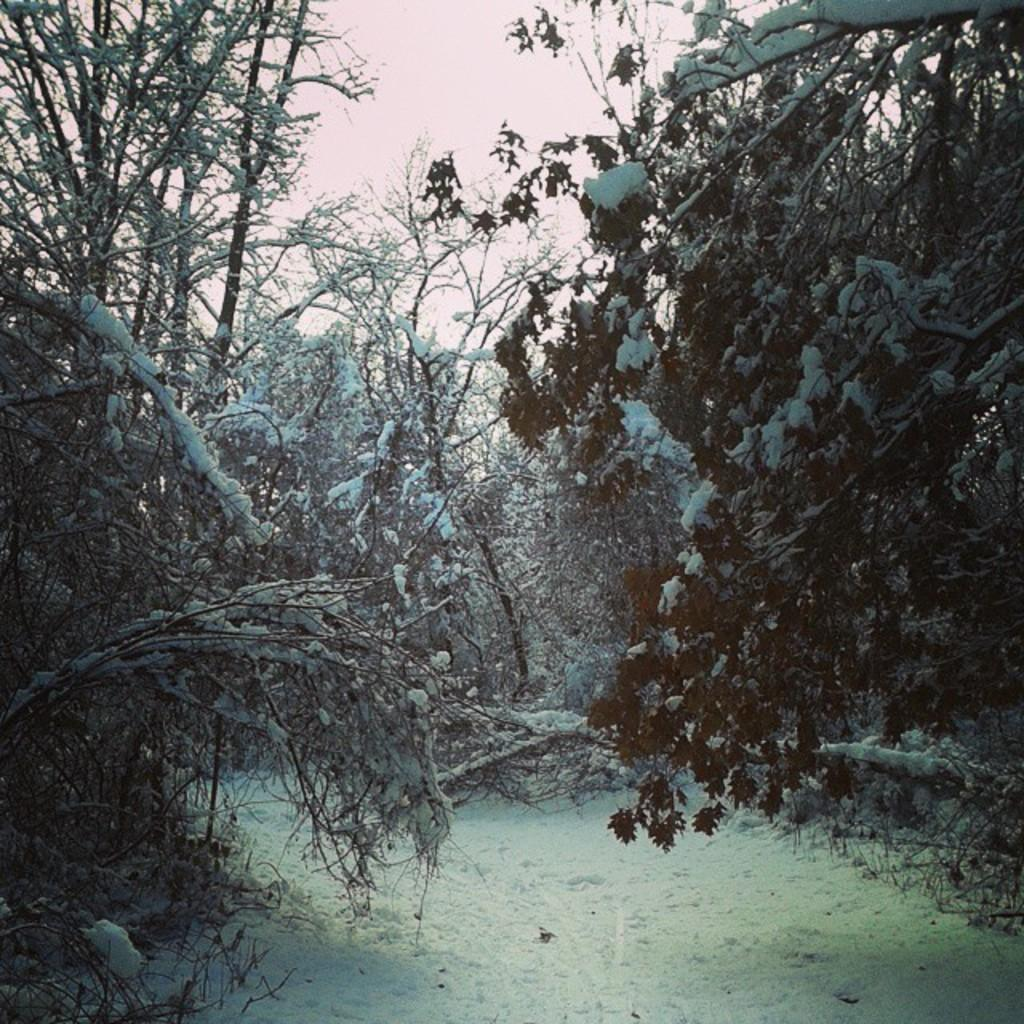What type of weather condition is depicted in the image? There is snow on the trees, indicating a winter scene. How many police officers are present in the image? There are no police officers present in the image; it only shows snow on the trees. What type of salt is used to melt the snow in the image? There is no salt present in the image, as it only shows snow on the trees. 